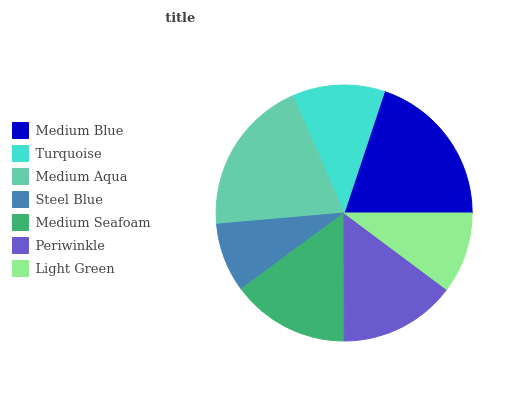Is Steel Blue the minimum?
Answer yes or no. Yes. Is Medium Blue the maximum?
Answer yes or no. Yes. Is Turquoise the minimum?
Answer yes or no. No. Is Turquoise the maximum?
Answer yes or no. No. Is Medium Blue greater than Turquoise?
Answer yes or no. Yes. Is Turquoise less than Medium Blue?
Answer yes or no. Yes. Is Turquoise greater than Medium Blue?
Answer yes or no. No. Is Medium Blue less than Turquoise?
Answer yes or no. No. Is Periwinkle the high median?
Answer yes or no. Yes. Is Periwinkle the low median?
Answer yes or no. Yes. Is Medium Aqua the high median?
Answer yes or no. No. Is Turquoise the low median?
Answer yes or no. No. 